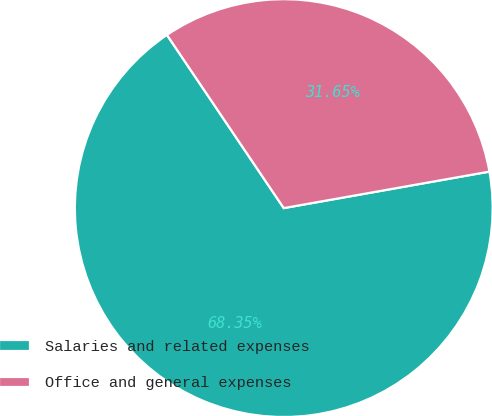<chart> <loc_0><loc_0><loc_500><loc_500><pie_chart><fcel>Salaries and related expenses<fcel>Office and general expenses<nl><fcel>68.35%<fcel>31.65%<nl></chart> 